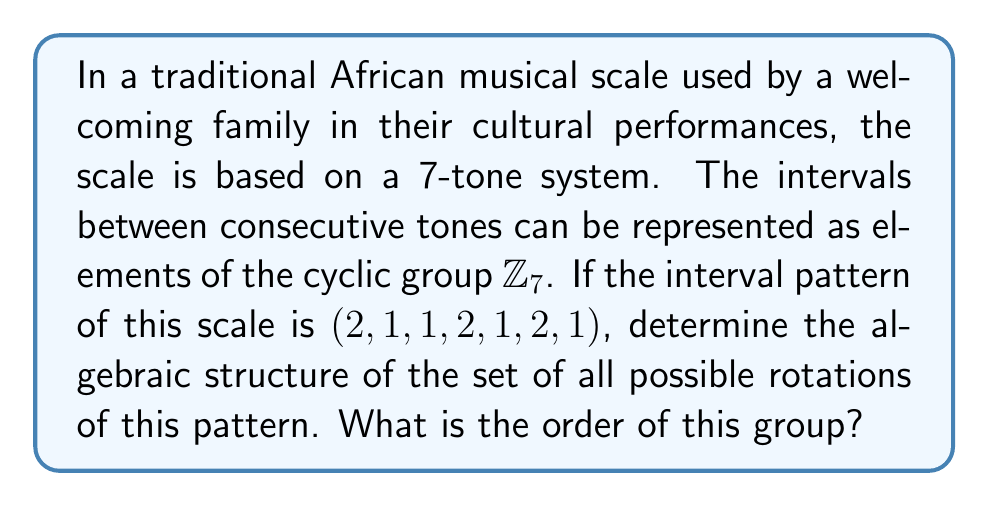Can you answer this question? To analyze the algebraic structure of the rotations of this African musical scale, we can follow these steps:

1) First, let's represent the scale pattern as a vector in $\mathbb{Z}_7^7$:
   $v = (2, 1, 1, 2, 1, 2, 1)$

2) The set of all rotations of this pattern forms a cyclic subgroup of the symmetric group $S_7$. Let's call this subgroup $G$.

3) To determine the order of $G$, we need to find the smallest positive integer $n$ such that $n$ rotations bring us back to the original pattern.

4) Let's list out the rotations:
   $v_1 = (2, 1, 1, 2, 1, 2, 1)$ (original)
   $v_2 = (1, 1, 2, 1, 2, 1, 2)$
   $v_3 = (1, 2, 1, 2, 1, 2, 1)$
   $v_4 = (2, 1, 2, 1, 2, 1, 1)$
   $v_5 = (1, 2, 1, 2, 1, 1, 2)$
   $v_6 = (2, 1, 2, 1, 1, 2, 1)$
   $v_7 = (1, 2, 1, 1, 2, 1, 2)$

5) We can see that after 7 rotations, we return to the original pattern. This means that the order of the group $G$ is 7.

6) Since the order is a prime number, $G$ is isomorphic to the cyclic group $\mathbb{Z}_7$.

Therefore, the algebraic structure of the set of all possible rotations of this pattern is a cyclic group of order 7, isomorphic to $\mathbb{Z}_7$.
Answer: The algebraic structure of the set of all possible rotations of the given African musical scale pattern is a cyclic group isomorphic to $\mathbb{Z}_7$, with order 7. 